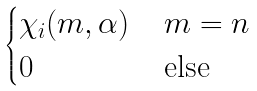<formula> <loc_0><loc_0><loc_500><loc_500>\begin{cases} \chi _ { i } ( m , \alpha ) & \, m = n \\ 0 & \, \text {else} \end{cases}</formula> 